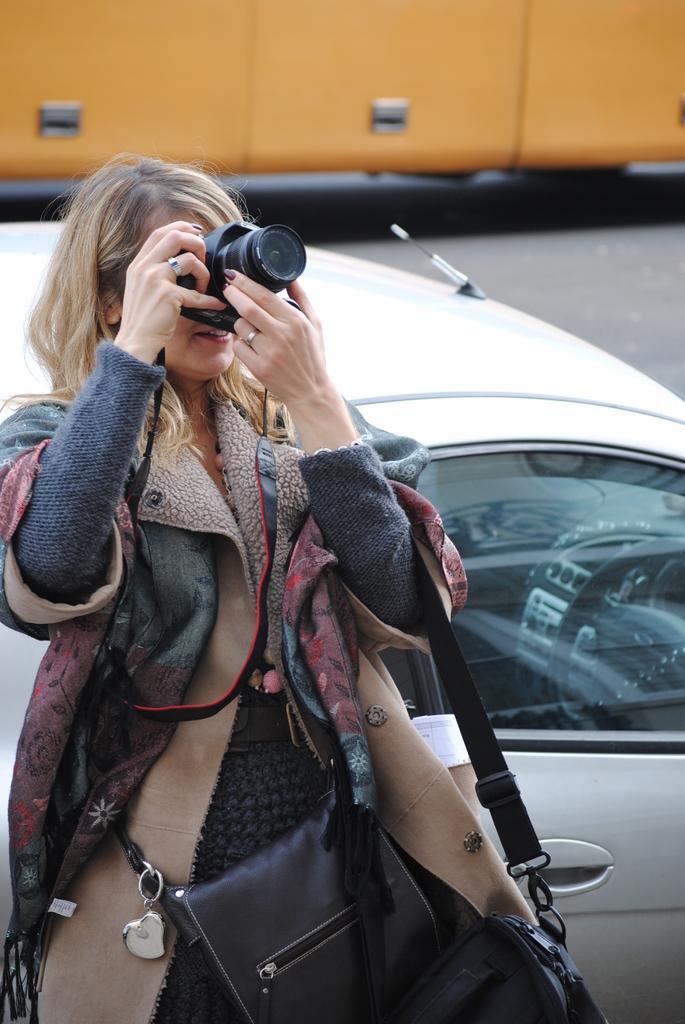In one or two sentences, can you explain what this image depicts? In the picture there is a woman capturing an image with the camera she is carrying a bag there is a car behind the women there is a road. 